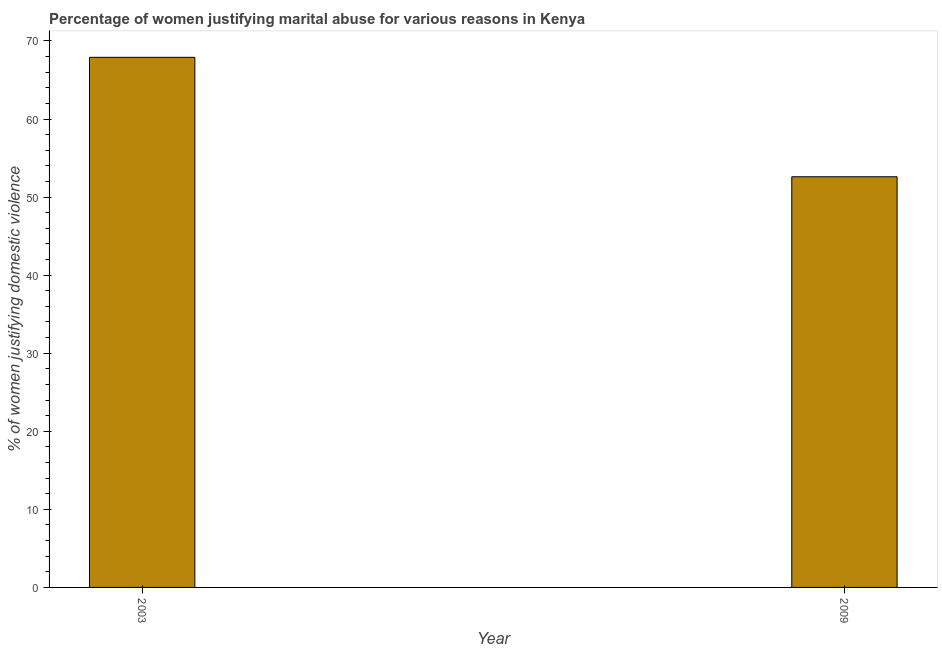What is the title of the graph?
Offer a terse response. Percentage of women justifying marital abuse for various reasons in Kenya. What is the label or title of the X-axis?
Your response must be concise. Year. What is the label or title of the Y-axis?
Offer a very short reply. % of women justifying domestic violence. What is the percentage of women justifying marital abuse in 2009?
Provide a short and direct response. 52.6. Across all years, what is the maximum percentage of women justifying marital abuse?
Offer a very short reply. 67.9. Across all years, what is the minimum percentage of women justifying marital abuse?
Make the answer very short. 52.6. In which year was the percentage of women justifying marital abuse maximum?
Give a very brief answer. 2003. In which year was the percentage of women justifying marital abuse minimum?
Provide a short and direct response. 2009. What is the sum of the percentage of women justifying marital abuse?
Make the answer very short. 120.5. What is the average percentage of women justifying marital abuse per year?
Your answer should be very brief. 60.25. What is the median percentage of women justifying marital abuse?
Provide a short and direct response. 60.25. What is the ratio of the percentage of women justifying marital abuse in 2003 to that in 2009?
Keep it short and to the point. 1.29. Is the percentage of women justifying marital abuse in 2003 less than that in 2009?
Offer a very short reply. No. Are all the bars in the graph horizontal?
Make the answer very short. No. How many years are there in the graph?
Keep it short and to the point. 2. Are the values on the major ticks of Y-axis written in scientific E-notation?
Provide a short and direct response. No. What is the % of women justifying domestic violence in 2003?
Provide a short and direct response. 67.9. What is the % of women justifying domestic violence in 2009?
Your answer should be very brief. 52.6. What is the difference between the % of women justifying domestic violence in 2003 and 2009?
Offer a terse response. 15.3. What is the ratio of the % of women justifying domestic violence in 2003 to that in 2009?
Provide a short and direct response. 1.29. 